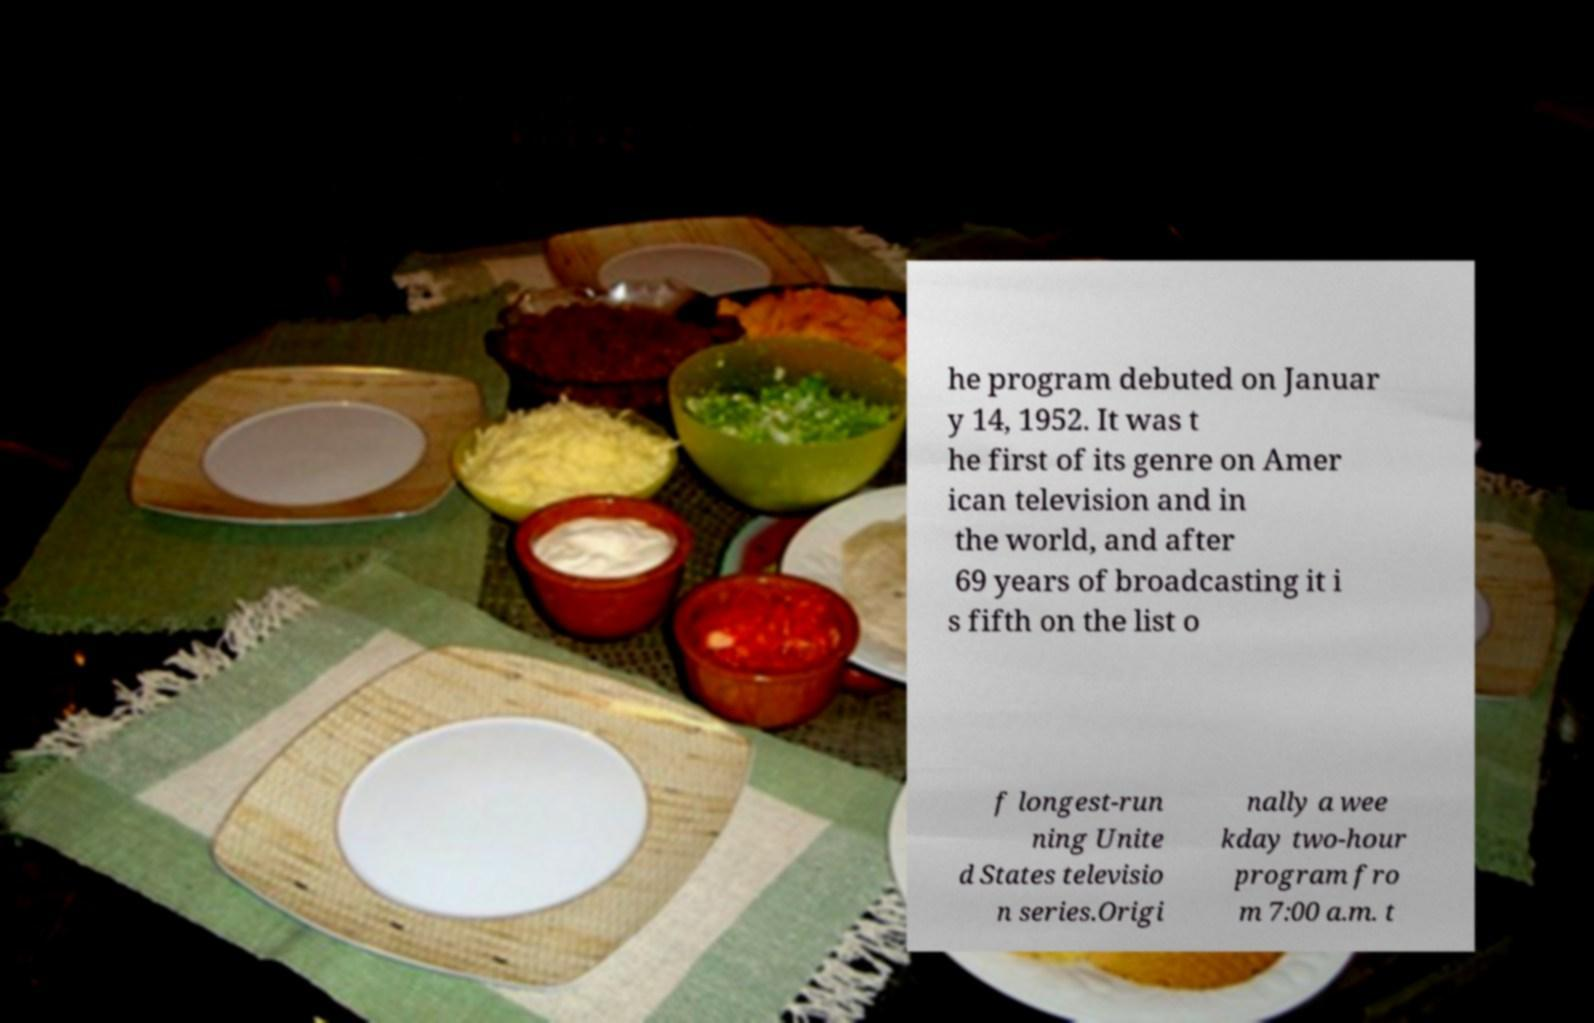Please identify and transcribe the text found in this image. he program debuted on Januar y 14, 1952. It was t he first of its genre on Amer ican television and in the world, and after 69 years of broadcasting it i s fifth on the list o f longest-run ning Unite d States televisio n series.Origi nally a wee kday two-hour program fro m 7:00 a.m. t 